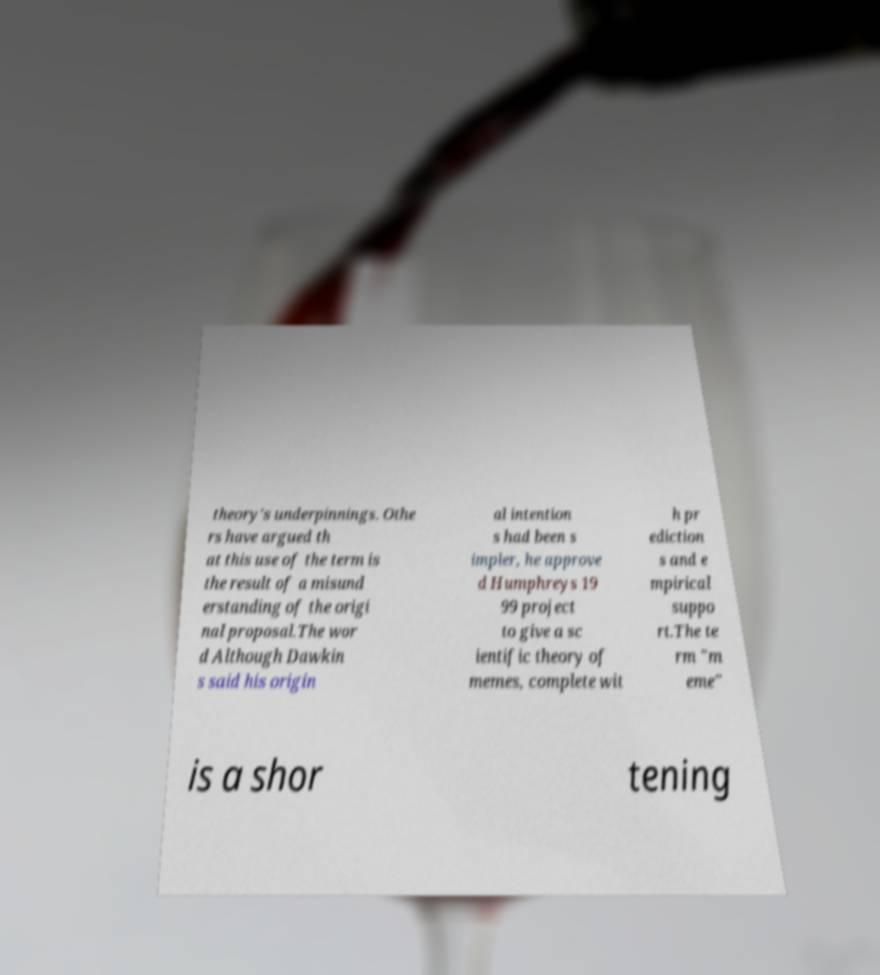There's text embedded in this image that I need extracted. Can you transcribe it verbatim? theory's underpinnings. Othe rs have argued th at this use of the term is the result of a misund erstanding of the origi nal proposal.The wor d Although Dawkin s said his origin al intention s had been s impler, he approve d Humphreys 19 99 project to give a sc ientific theory of memes, complete wit h pr ediction s and e mpirical suppo rt.The te rm "m eme" is a shor tening 